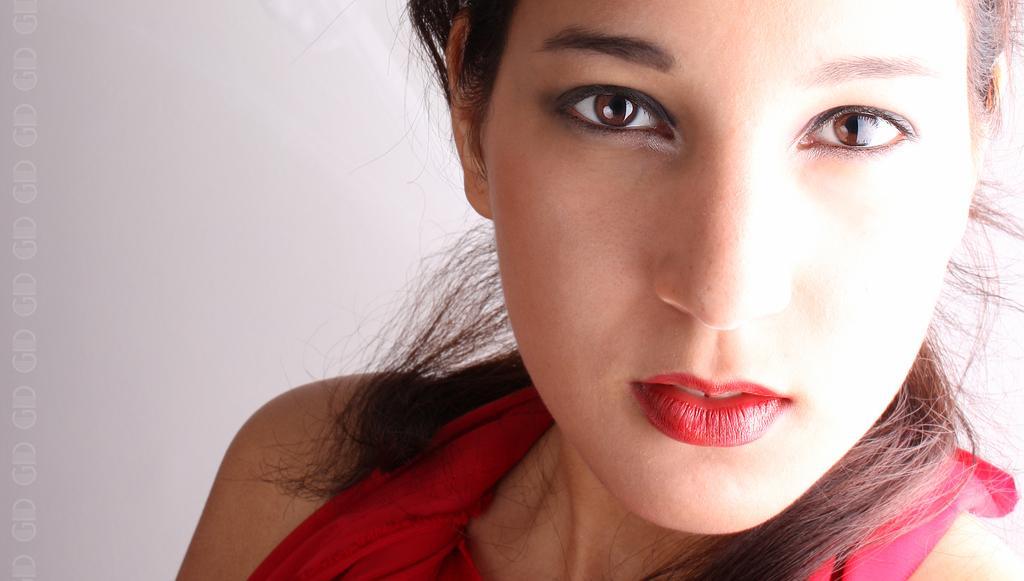Please provide a concise description of this image. In this image the background is gray in color. On the right side of the image there is a girl. She has worn a red dress and a red lipstick on her lips. 